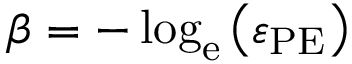Convert formula to latex. <formula><loc_0><loc_0><loc_500><loc_500>\beta = - \log _ { e } \left ( \varepsilon _ { P E } \right )</formula> 